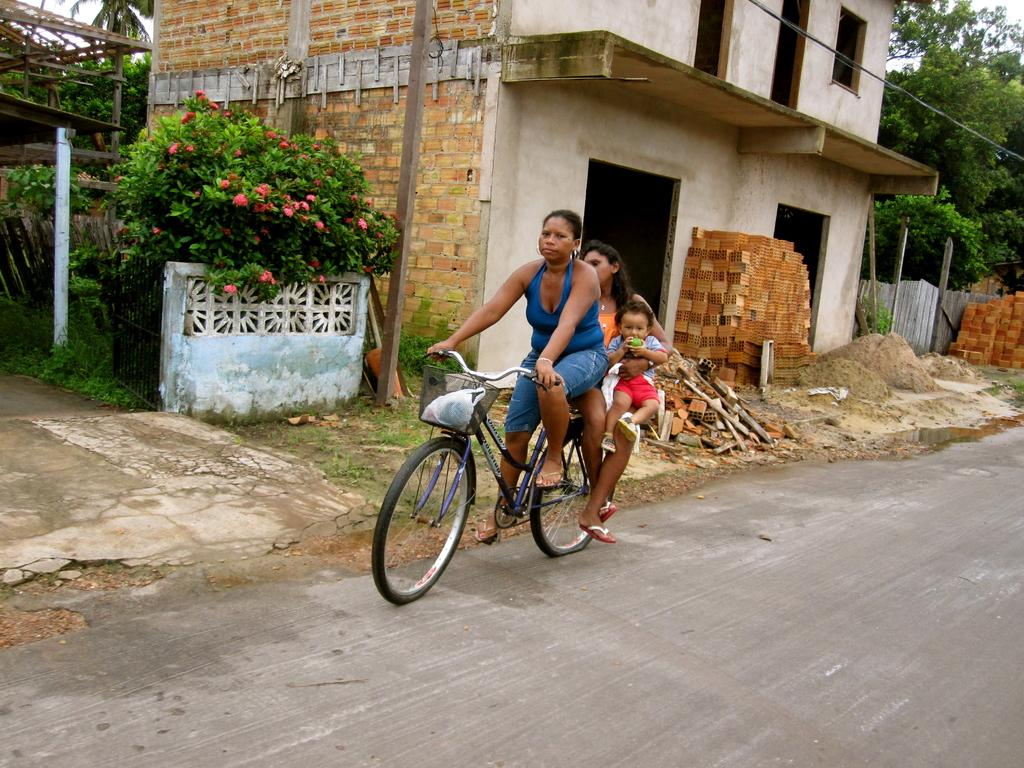What are the persons in the image doing? The persons in the image are on a bicycle. What can be seen in the background of the image? There is a road, trees, and a building in the image. Are there any natural elements present in the image? Yes, there are flowers in the image. What type of button can be seen being exchanged between the persons on the bicycle in the image? There is no button being exchanged between the persons on the bicycle in the image. Can you see a kite flying in the image? There is no kite present in the image. 